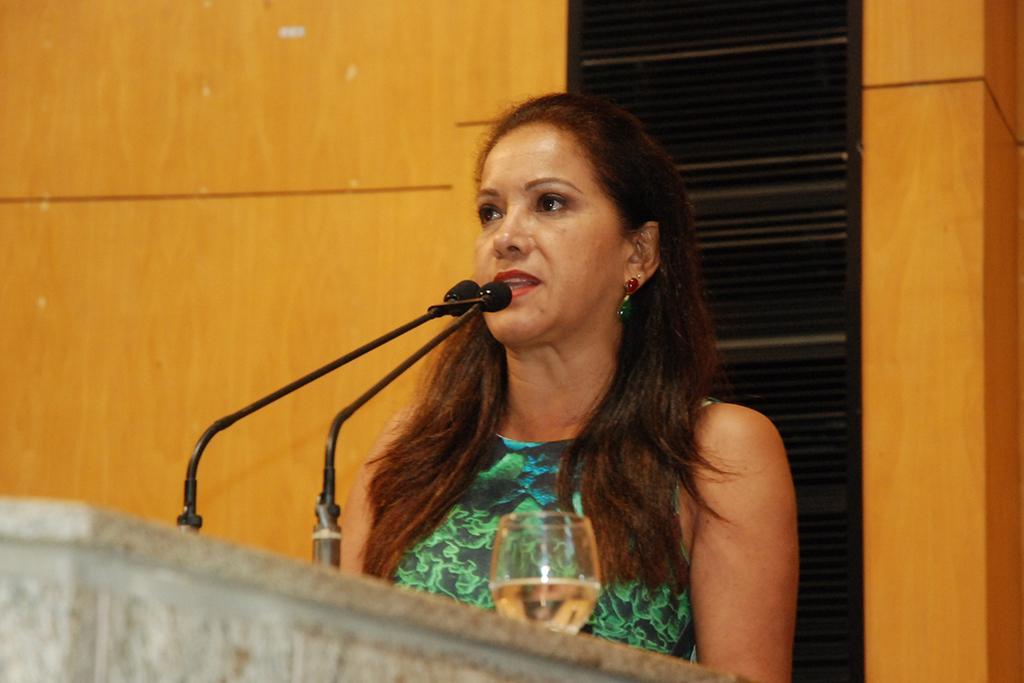Can you describe this image briefly? In this picture I can observe a woman in the middle of the picture. In front of the woman there is a podium on which I can observe two mics and a glass. Woman is wearing green color dress. In the background I can observe wall. 